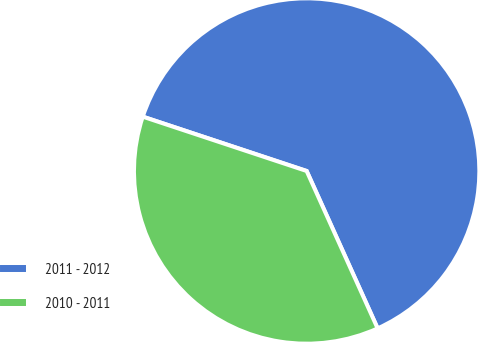<chart> <loc_0><loc_0><loc_500><loc_500><pie_chart><fcel>2011 - 2012<fcel>2010 - 2011<nl><fcel>63.16%<fcel>36.84%<nl></chart> 